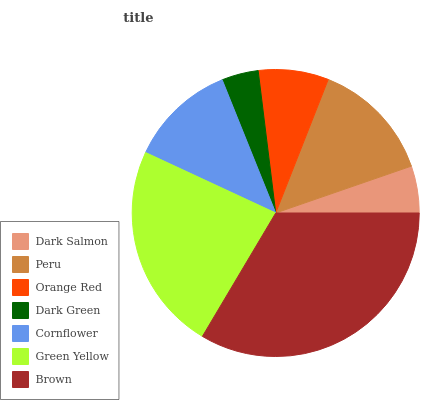Is Dark Green the minimum?
Answer yes or no. Yes. Is Brown the maximum?
Answer yes or no. Yes. Is Peru the minimum?
Answer yes or no. No. Is Peru the maximum?
Answer yes or no. No. Is Peru greater than Dark Salmon?
Answer yes or no. Yes. Is Dark Salmon less than Peru?
Answer yes or no. Yes. Is Dark Salmon greater than Peru?
Answer yes or no. No. Is Peru less than Dark Salmon?
Answer yes or no. No. Is Cornflower the high median?
Answer yes or no. Yes. Is Cornflower the low median?
Answer yes or no. Yes. Is Brown the high median?
Answer yes or no. No. Is Green Yellow the low median?
Answer yes or no. No. 